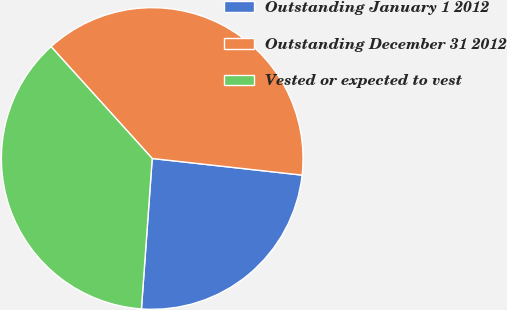Convert chart to OTSL. <chart><loc_0><loc_0><loc_500><loc_500><pie_chart><fcel>Outstanding January 1 2012<fcel>Outstanding December 31 2012<fcel>Vested or expected to vest<nl><fcel>24.38%<fcel>38.46%<fcel>37.16%<nl></chart> 